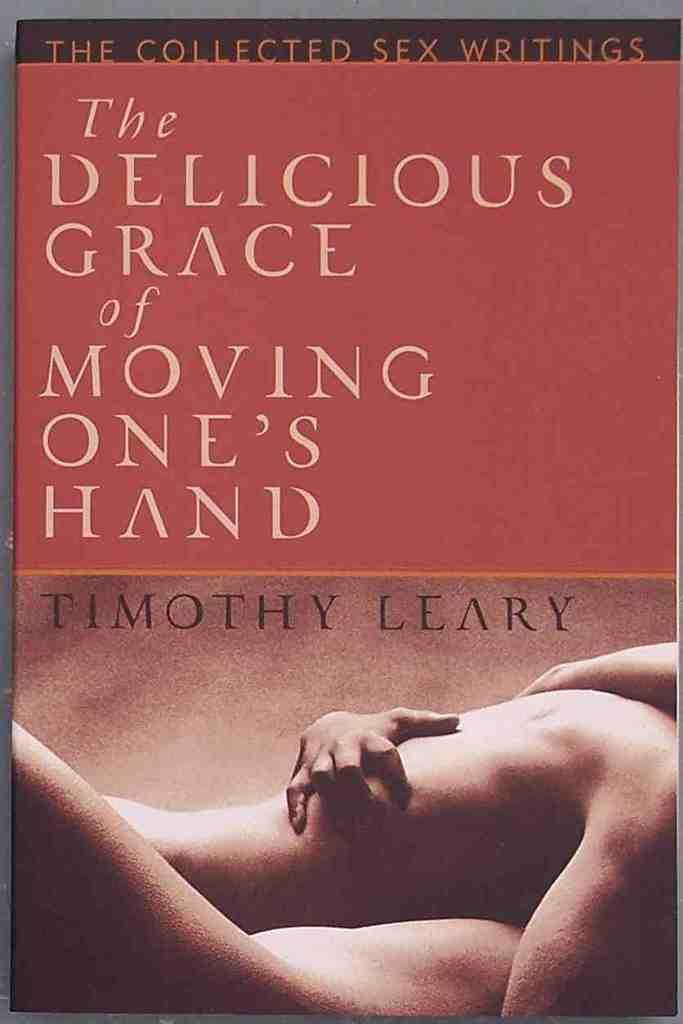<image>
Present a compact description of the photo's key features. The cover of a book written by Timothy Leary 